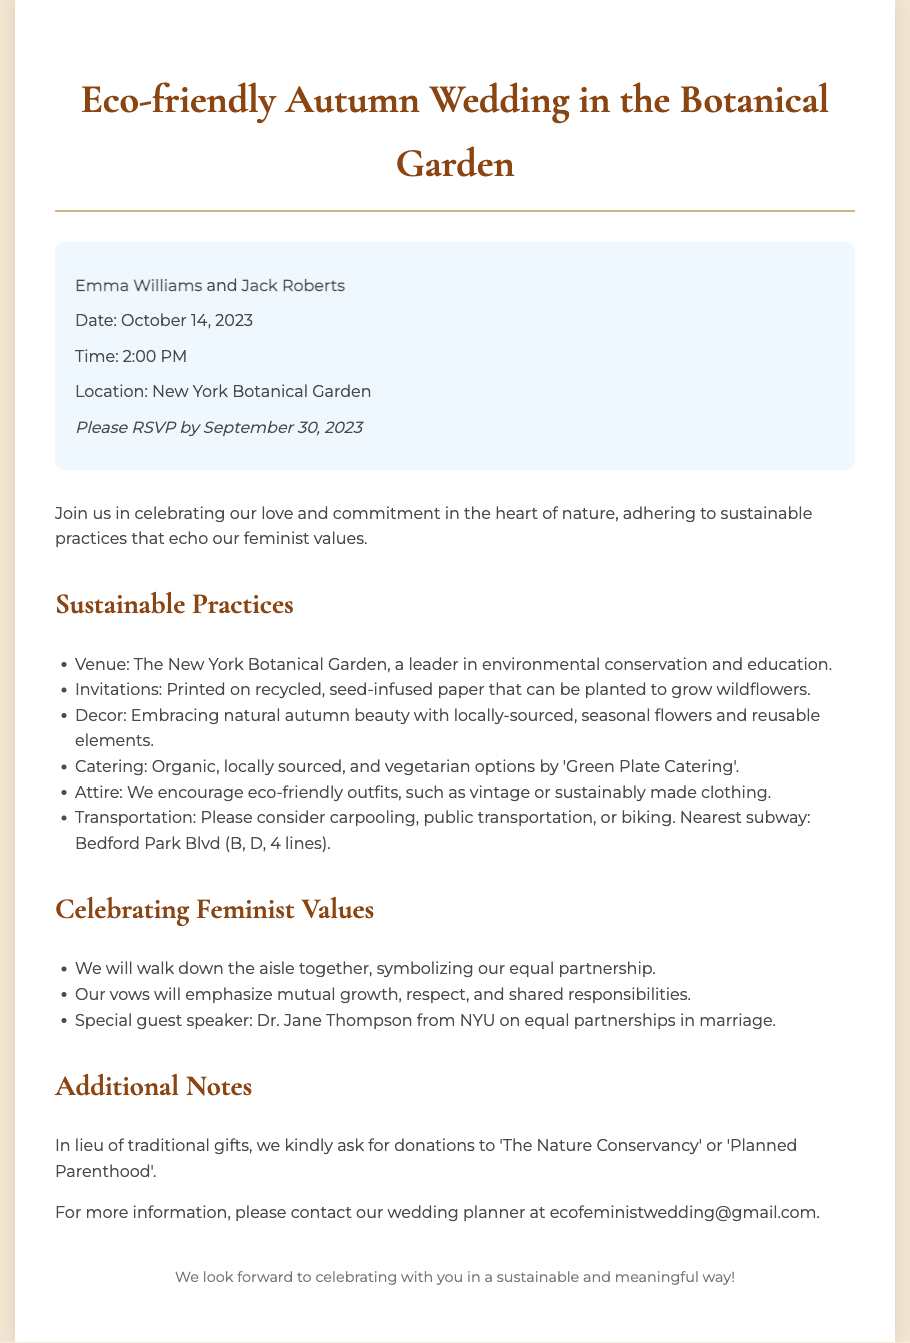what are the names of the couple? The names of the couple getting married are specifically mentioned at the beginning of the document.
Answer: Emma Williams and Jack Roberts what is the wedding date? The wedding date is clearly stated in the event details section of the document.
Answer: October 14, 2023 where is the wedding located? The location of the wedding is indicated in the event details, specifying where the ceremony will take place.
Answer: New York Botanical Garden what type of catering will be provided? The catering information highlights the type of food that will be served during the wedding, focusing on sustainability.
Answer: Organic, locally sourced, and vegetarian options how should guests travel to the wedding? The invitation suggests environmentally friendly transportation options for guests, which are listed under sustainable practices.
Answer: Carpooling, public transportation, or biking what is the purpose of the seeded invitations? The invitations are described in relation to their sustainability practices, specifically mentioning their unique quality.
Answer: To grow wildflowers what will the couple emphasize in their vows? The document indicates key themes that the couple will focus on during their vows, reflecting their values.
Answer: Mutual growth, respect, and shared responsibilities who is the special guest speaker? The identity of the special guest speaker is mentioned in the section celebrating feminist values, highlighting their role at the wedding.
Answer: Dr. Jane Thompson what donations are requested instead of gifts? The invitation notes the couple's preference for contributions instead of traditional wedding gifts.
Answer: The Nature Conservancy or Planned Parenthood 